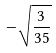<formula> <loc_0><loc_0><loc_500><loc_500>- \sqrt { \frac { 3 } { 3 5 } }</formula> 